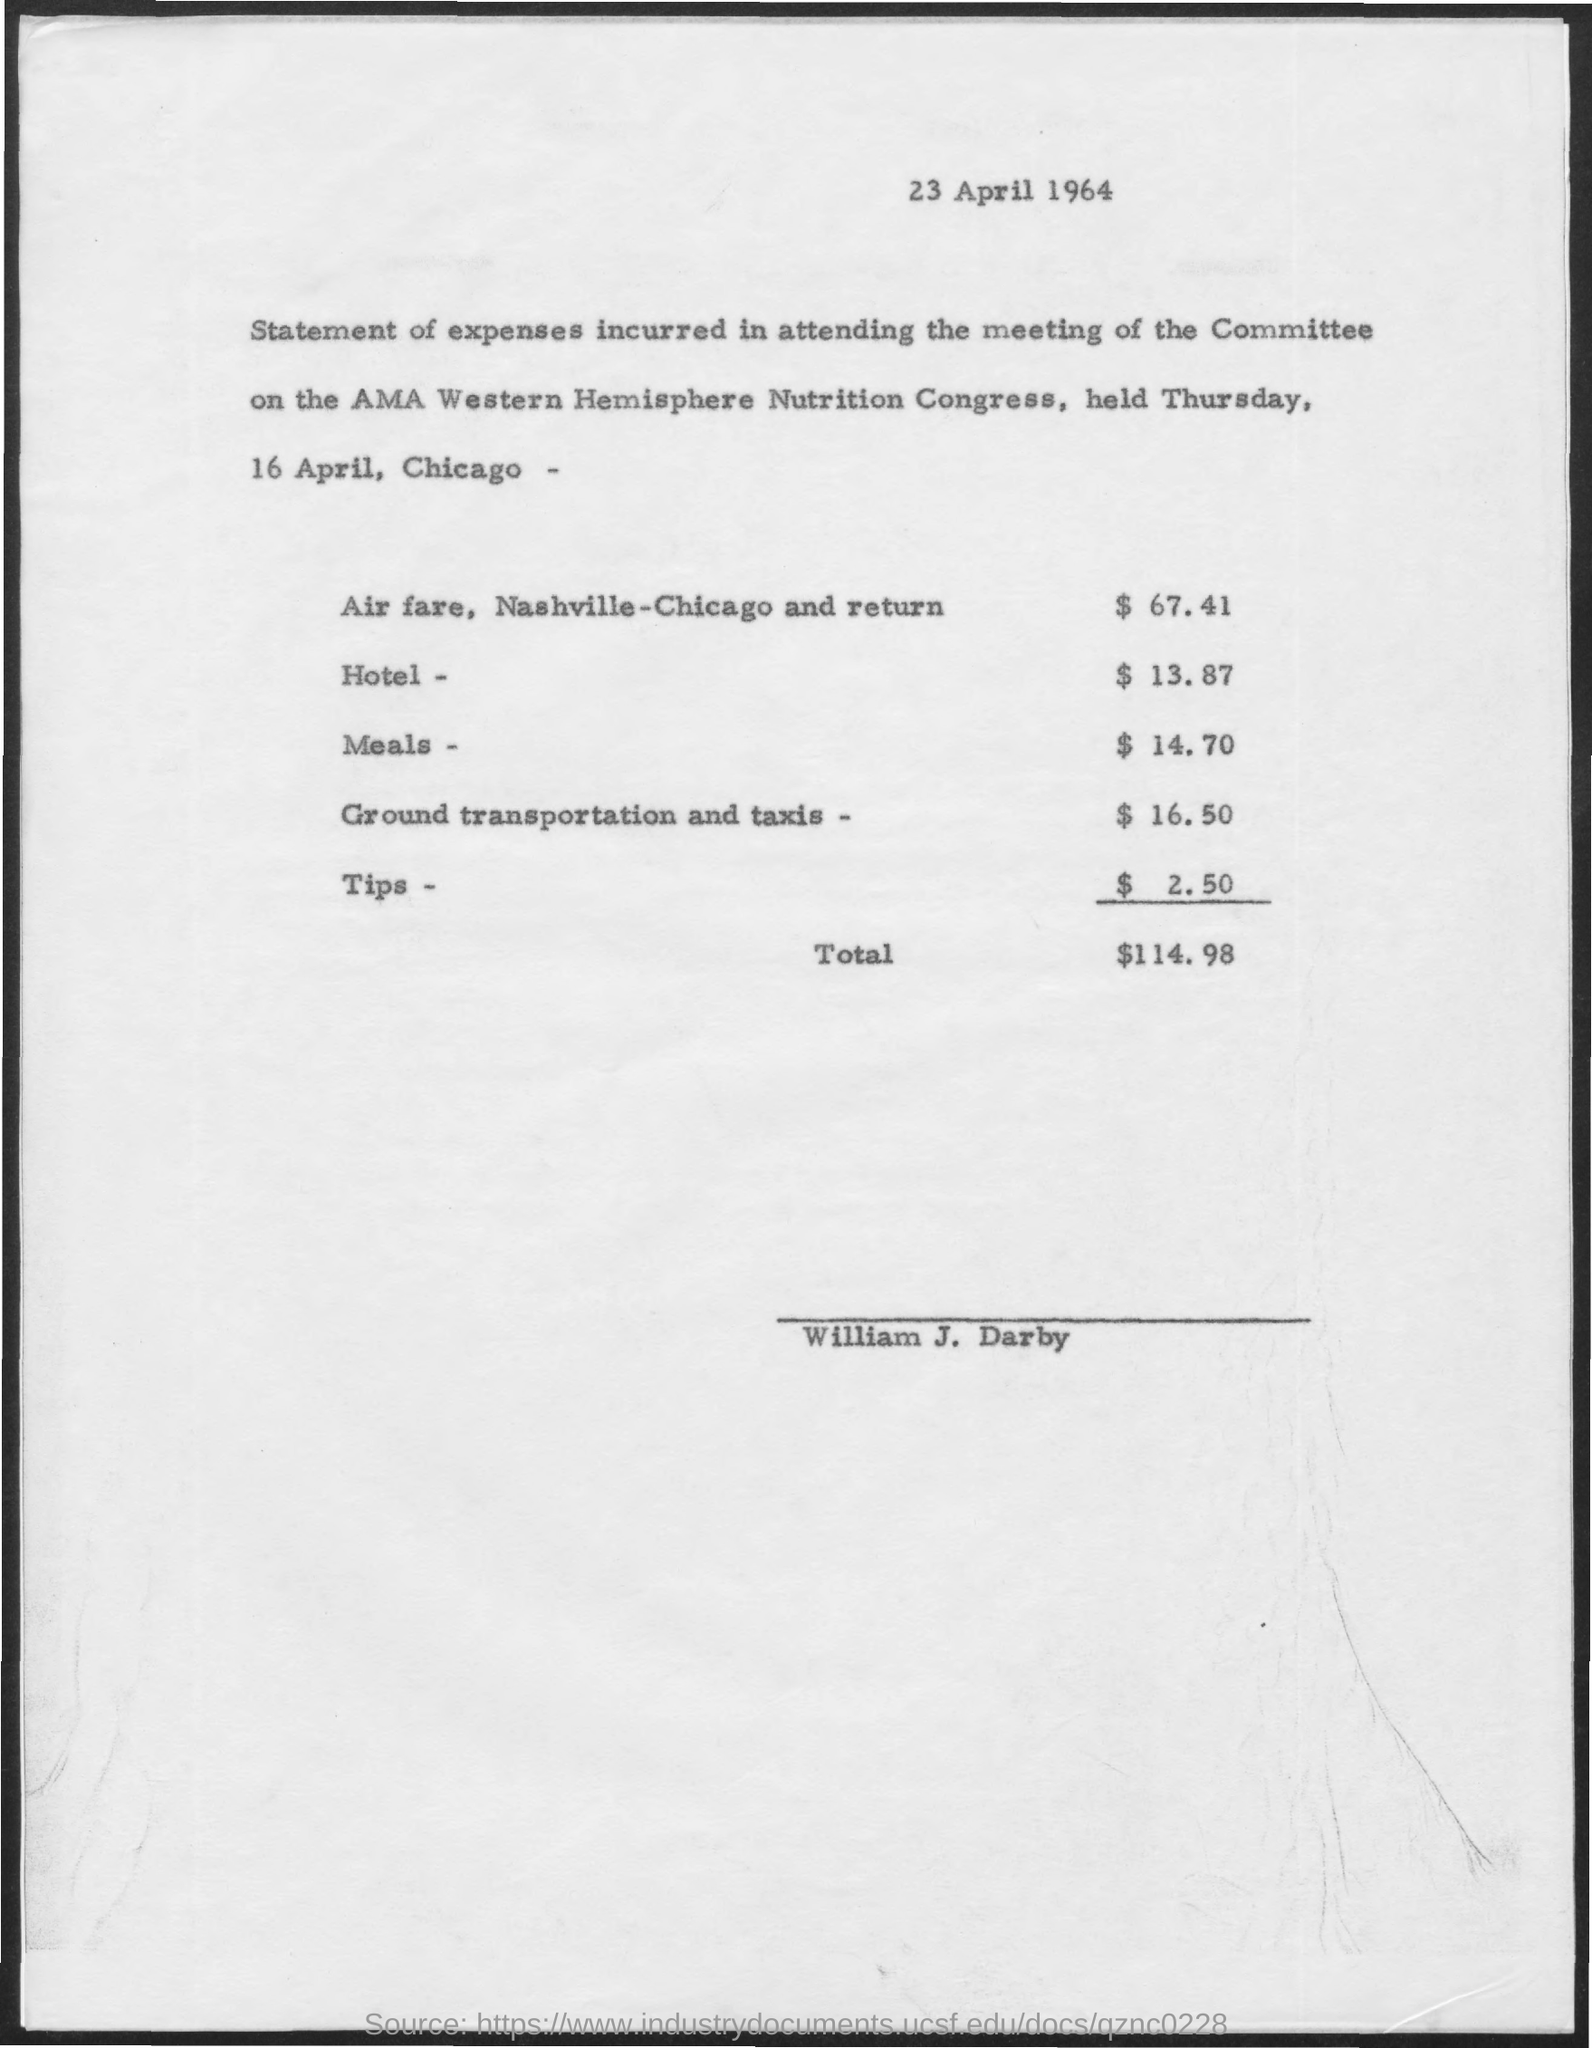What is the date mentioned at the top of the document?
Your answer should be compact. 23 April 1964. What is the Total?
Keep it short and to the point. $114.98. What is the name of the person mentioned in the document?
Your response must be concise. William J. Darby. What is the price for meals?
Provide a short and direct response. 14.70. 